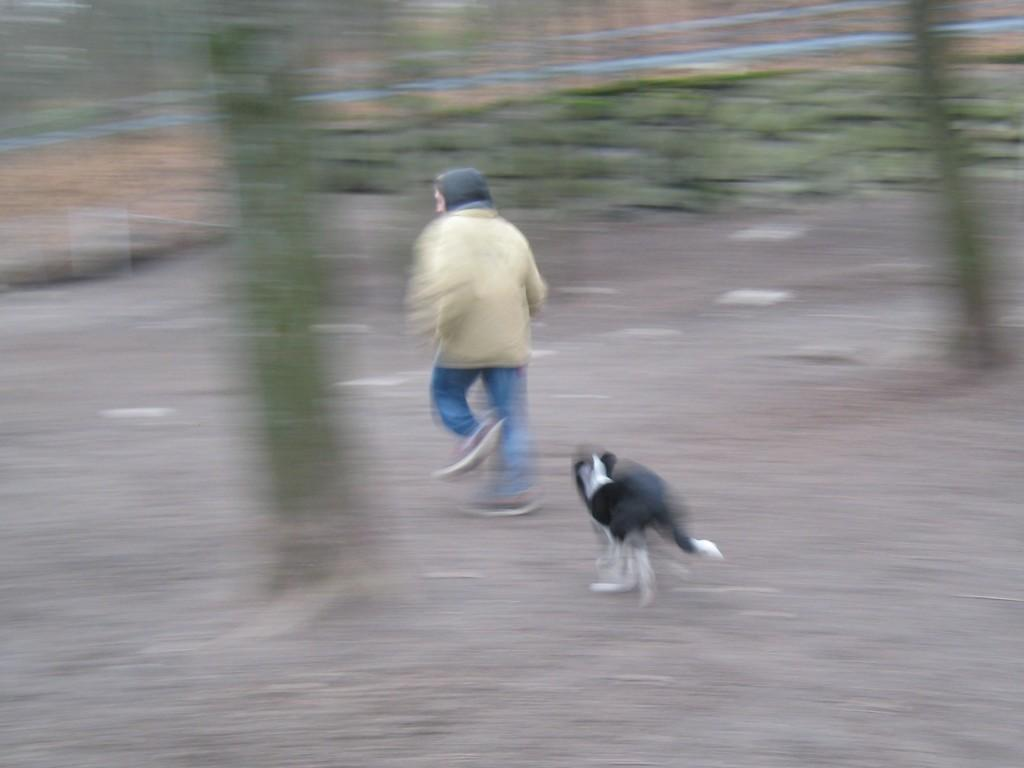What is the main action being performed by the person in the image? The person is running in the image. Can you describe the reason for the person's running? The person is running due to a dog. How many girls are present in the image? There is no mention of girls in the provided facts, so it cannot be determined from the image. 